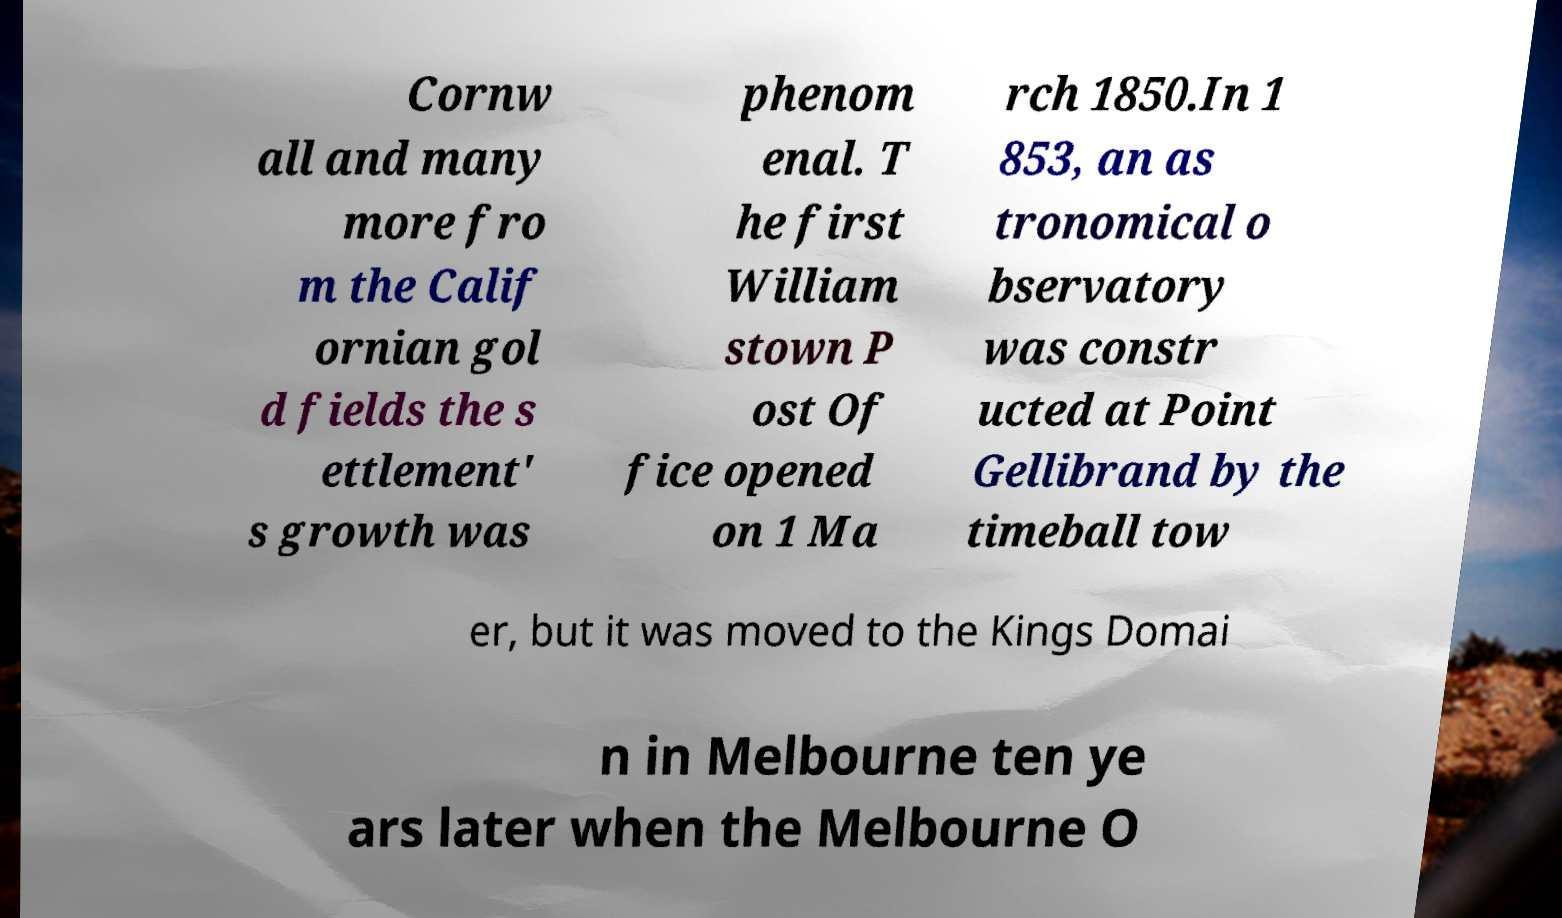Please identify and transcribe the text found in this image. Cornw all and many more fro m the Calif ornian gol d fields the s ettlement' s growth was phenom enal. T he first William stown P ost Of fice opened on 1 Ma rch 1850.In 1 853, an as tronomical o bservatory was constr ucted at Point Gellibrand by the timeball tow er, but it was moved to the Kings Domai n in Melbourne ten ye ars later when the Melbourne O 